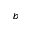Convert formula to latex. <formula><loc_0><loc_0><loc_500><loc_500>b</formula> 